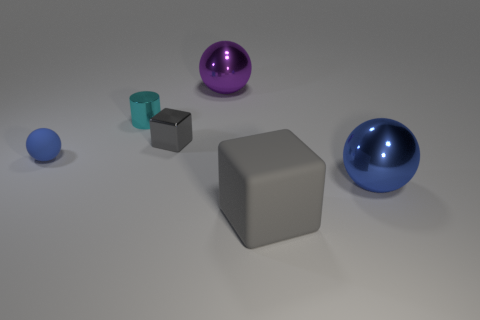What number of small blue things are the same shape as the purple metallic thing?
Ensure brevity in your answer.  1. What shape is the small thing that is made of the same material as the tiny gray block?
Provide a short and direct response. Cylinder. How many green objects are either matte blocks or metal cubes?
Your response must be concise. 0. Are there any large purple spheres in front of the cyan shiny cylinder?
Give a very brief answer. No. There is a thing that is to the left of the tiny cyan thing; is it the same shape as the big shiny thing right of the purple metallic thing?
Give a very brief answer. Yes. What material is the purple object that is the same shape as the large blue object?
Ensure brevity in your answer.  Metal. What number of blocks are either big gray matte things or gray objects?
Your response must be concise. 2. How many tiny cylinders are the same material as the large gray block?
Give a very brief answer. 0. Are the large ball in front of the cyan cylinder and the blue ball that is on the left side of the large blue metallic ball made of the same material?
Keep it short and to the point. No. There is a big thing behind the gray cube that is left of the big matte thing; how many tiny blocks are behind it?
Provide a succinct answer. 0. 